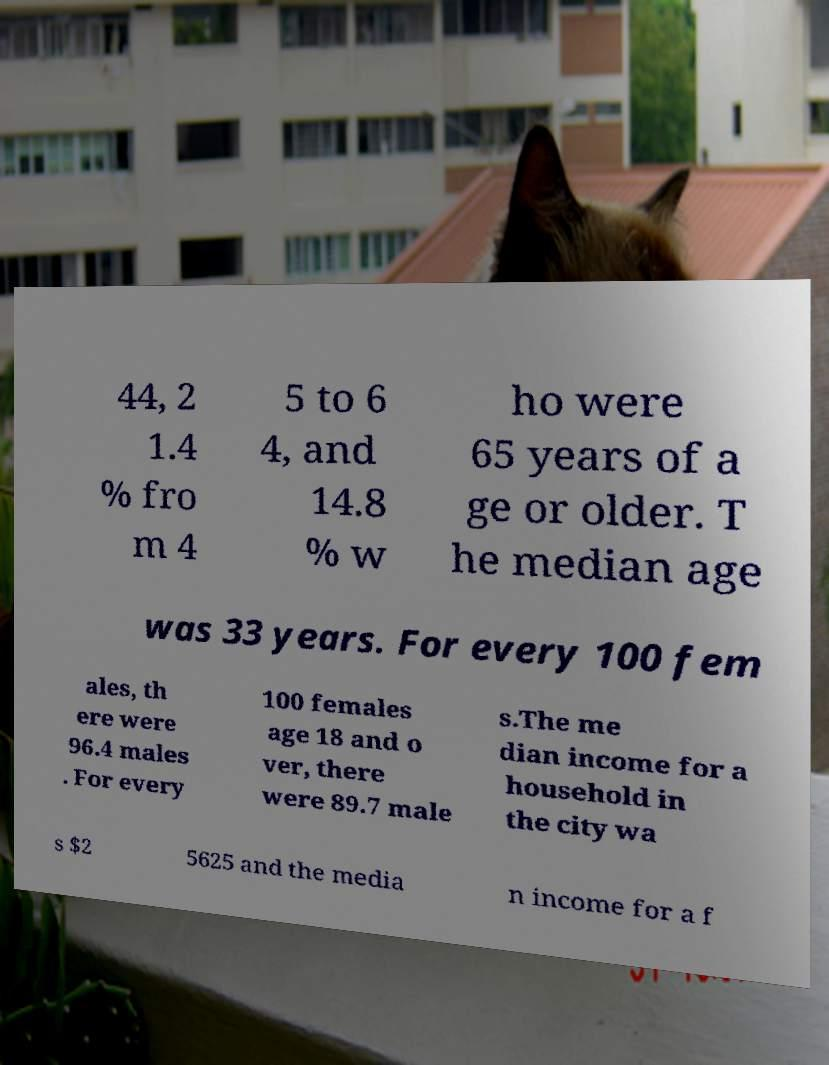I need the written content from this picture converted into text. Can you do that? 44, 2 1.4 % fro m 4 5 to 6 4, and 14.8 % w ho were 65 years of a ge or older. T he median age was 33 years. For every 100 fem ales, th ere were 96.4 males . For every 100 females age 18 and o ver, there were 89.7 male s.The me dian income for a household in the city wa s $2 5625 and the media n income for a f 